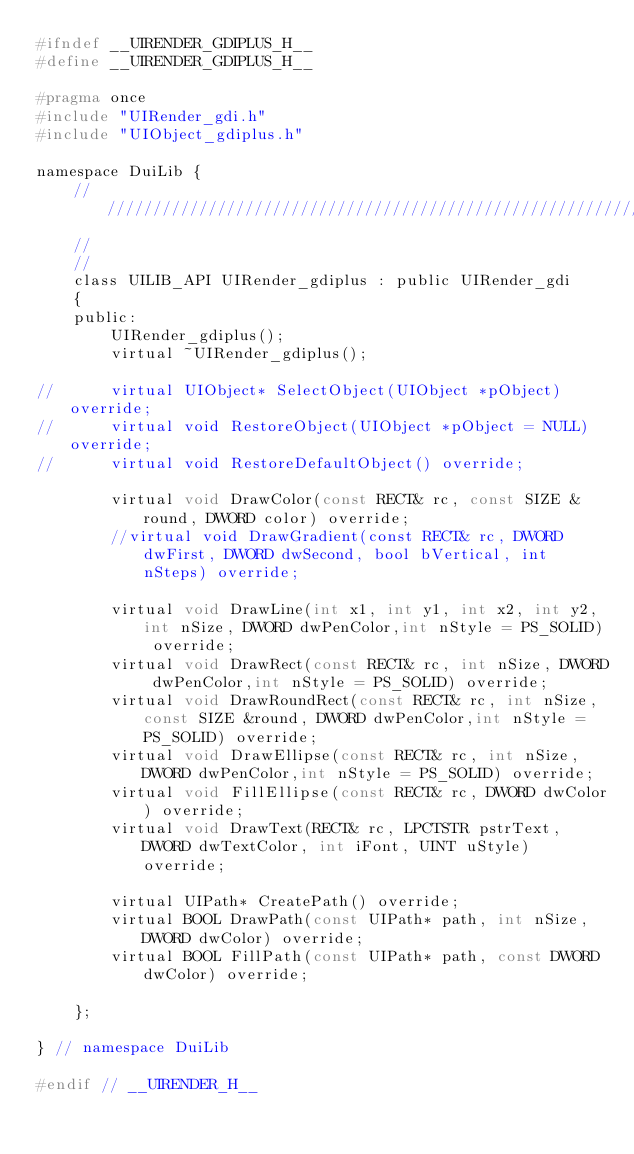Convert code to text. <code><loc_0><loc_0><loc_500><loc_500><_C_>#ifndef __UIRENDER_GDIPLUS_H__
#define __UIRENDER_GDIPLUS_H__

#pragma once
#include "UIRender_gdi.h"
#include "UIObject_gdiplus.h"

namespace DuiLib {
	/////////////////////////////////////////////////////////////////////////////////////
	//
	//
	class UILIB_API UIRender_gdiplus : public UIRender_gdi
	{
	public:
		UIRender_gdiplus();
		virtual ~UIRender_gdiplus();

// 		virtual UIObject* SelectObject(UIObject *pObject) override;
// 		virtual void RestoreObject(UIObject *pObject = NULL) override;
// 		virtual void RestoreDefaultObject() override;

		virtual void DrawColor(const RECT& rc, const SIZE &round, DWORD color) override;
		//virtual void DrawGradient(const RECT& rc, DWORD dwFirst, DWORD dwSecond, bool bVertical, int nSteps) override;

		virtual void DrawLine(int x1, int y1, int x2, int y2, int nSize, DWORD dwPenColor,int nStyle = PS_SOLID) override;
		virtual void DrawRect(const RECT& rc, int nSize, DWORD dwPenColor,int nStyle = PS_SOLID) override;
		virtual void DrawRoundRect(const RECT& rc, int nSize, const SIZE &round, DWORD dwPenColor,int nStyle = PS_SOLID) override;
		virtual void DrawEllipse(const RECT& rc, int nSize, DWORD dwPenColor,int nStyle = PS_SOLID) override;
		virtual void FillEllipse(const RECT& rc, DWORD dwColor) override;
		virtual void DrawText(RECT& rc, LPCTSTR pstrText, DWORD dwTextColor, int iFont, UINT uStyle) override;

		virtual UIPath* CreatePath() override;	
		virtual BOOL DrawPath(const UIPath* path, int nSize, DWORD dwColor) override;
		virtual BOOL FillPath(const UIPath* path, const DWORD dwColor) override;

	};

} // namespace DuiLib

#endif // __UIRENDER_H__
</code> 